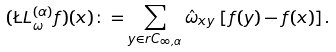Convert formula to latex. <formula><loc_0><loc_0><loc_500><loc_500>( \L L _ { \omega } ^ { ( \alpha ) } f ) ( x ) \colon = \sum _ { y \in r C _ { \infty , \alpha } } \hat { \omega } _ { x y } \, \left [ f ( y ) - f ( x ) \right ] .</formula> 